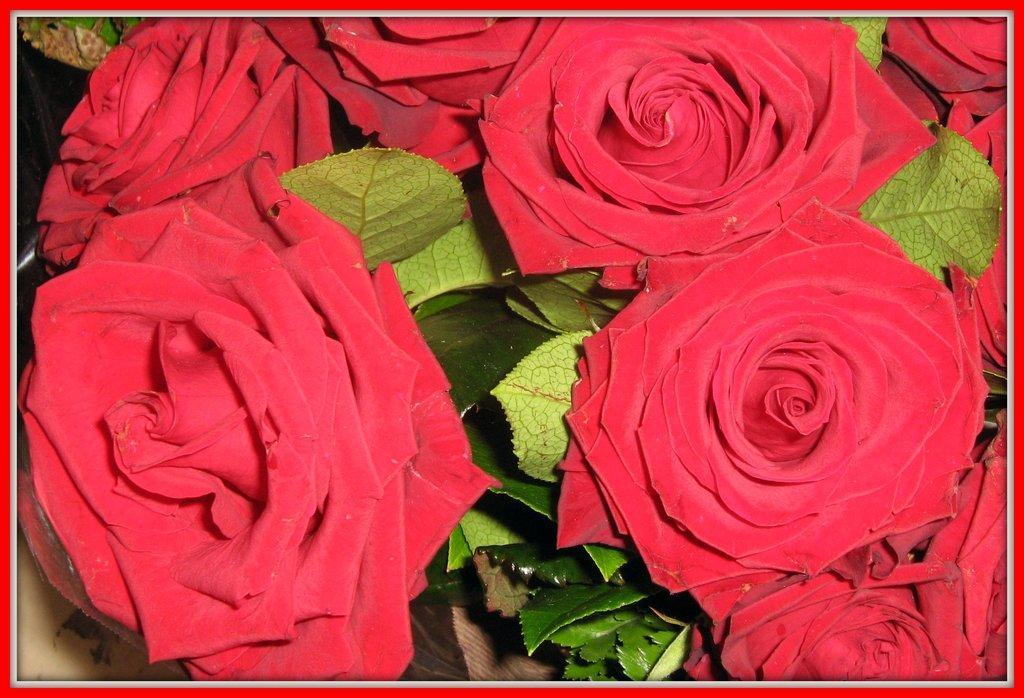Describe this image in one or two sentences. In this image we can see there are flowers and leaves. 